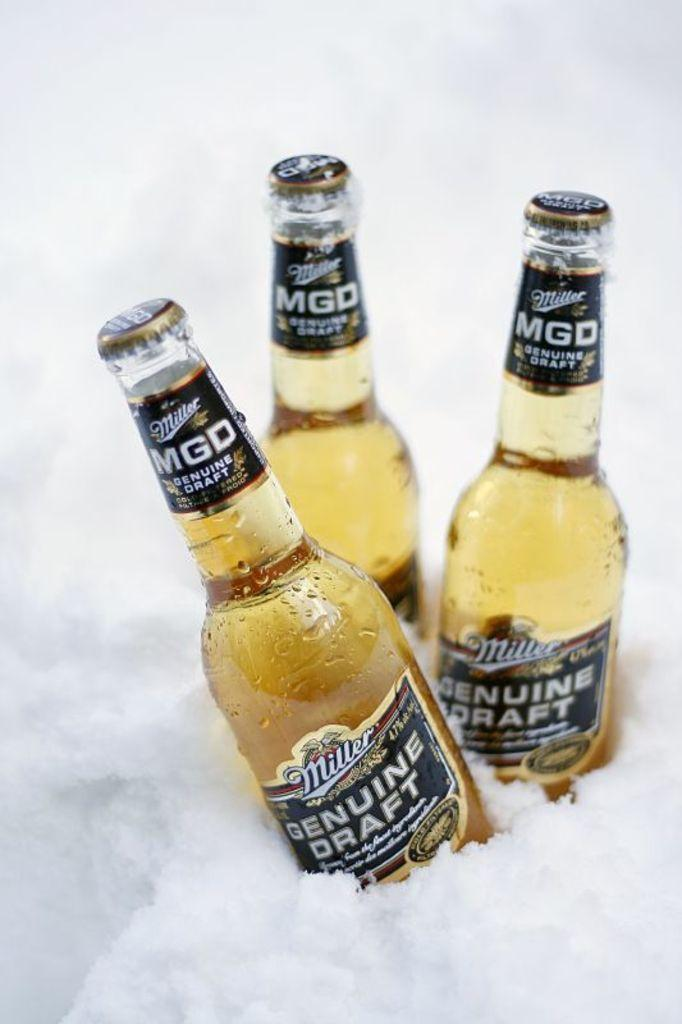<image>
Give a short and clear explanation of the subsequent image. Three bottles of Miller Genuine Draft sit in the snow. 